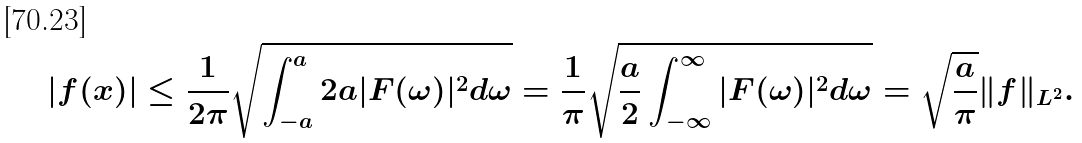Convert formula to latex. <formula><loc_0><loc_0><loc_500><loc_500>| f ( x ) | \leq { \frac { 1 } { 2 \pi } } { \sqrt { \int _ { - a } ^ { a } 2 a | F ( \omega ) | ^ { 2 } d \omega } } = { \frac { 1 } { \pi } } { \sqrt { { \frac { a } { 2 } } \int _ { - \infty } ^ { \infty } | F ( \omega ) | ^ { 2 } d \omega } } = { \sqrt { \frac { a } { \pi } } } \| f \| _ { L ^ { 2 } } .</formula> 